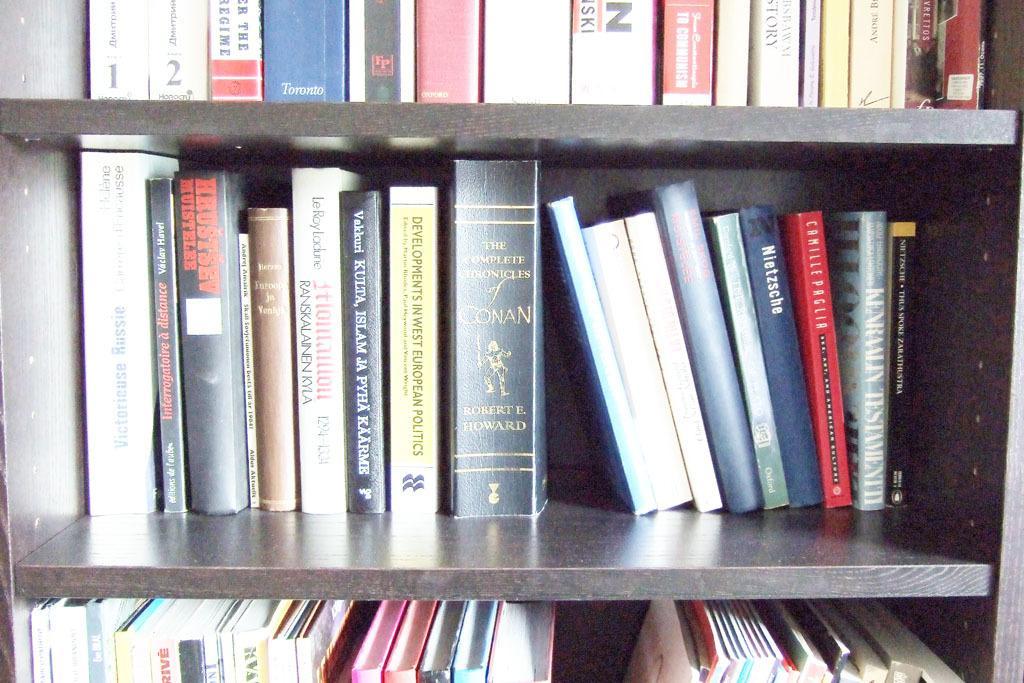Can you describe this image briefly? This picture seems to be clicked inside. In this picture we can see there are many number of books which are placed in the wooden cabinet and we can see the text and some pictures on the books. 